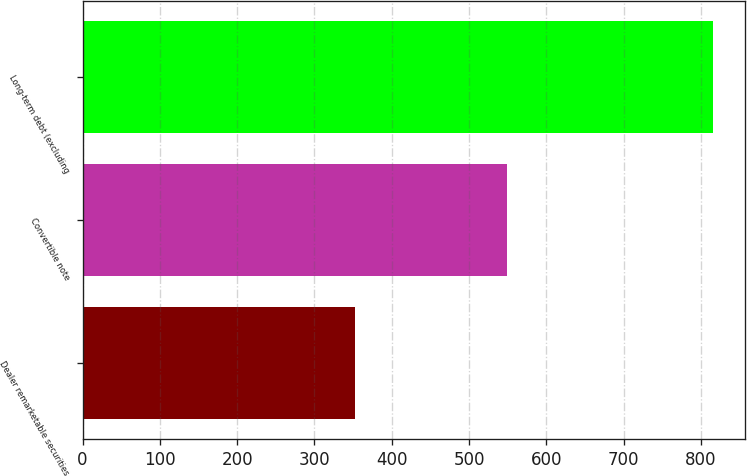Convert chart to OTSL. <chart><loc_0><loc_0><loc_500><loc_500><bar_chart><fcel>Dealer remarketable securities<fcel>Convertible note<fcel>Long-term debt (excluding<nl><fcel>352<fcel>549<fcel>816<nl></chart> 